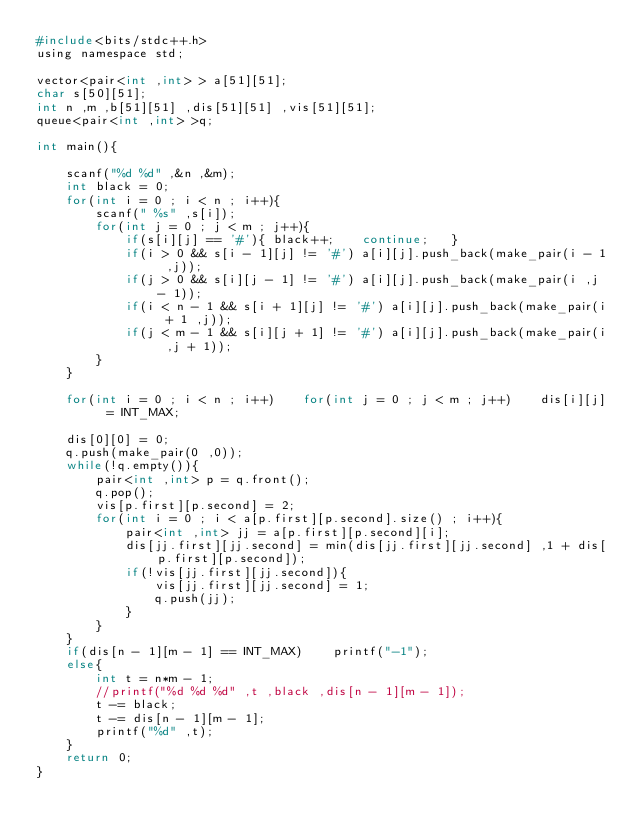Convert code to text. <code><loc_0><loc_0><loc_500><loc_500><_C_>#include<bits/stdc++.h>
using namespace std;

vector<pair<int ,int> > a[51][51];
char s[50][51];
int n ,m ,b[51][51] ,dis[51][51] ,vis[51][51];
queue<pair<int ,int> >q;

int main(){

	scanf("%d %d" ,&n ,&m);
	int black = 0;
	for(int i = 0 ; i < n ; i++){
		scanf(" %s" ,s[i]);
		for(int j = 0 ; j < m ; j++){
			if(s[i][j] == '#'){	black++;	continue;	}
			if(i > 0 && s[i - 1][j] != '#')	a[i][j].push_back(make_pair(i - 1 ,j));
			if(j > 0 && s[i][j - 1] != '#')	a[i][j].push_back(make_pair(i ,j - 1));
			if(i < n - 1 && s[i + 1][j] != '#')	a[i][j].push_back(make_pair(i + 1 ,j));
			if(j < m - 1 && s[i][j + 1] != '#')	a[i][j].push_back(make_pair(i ,j + 1));
		}
	}	
	
	for(int i = 0 ; i < n ; i++)	for(int j = 0 ; j < m ; j++)	dis[i][j] = INT_MAX;
	
	dis[0][0] = 0;
	q.push(make_pair(0 ,0));
	while(!q.empty()){
		pair<int ,int> p = q.front();
		q.pop();
		vis[p.first][p.second] = 2;
		for(int i = 0 ; i < a[p.first][p.second].size() ; i++){
			pair<int ,int> jj = a[p.first][p.second][i];
			dis[jj.first][jj.second] = min(dis[jj.first][jj.second] ,1 + dis[p.first][p.second]);
			if(!vis[jj.first][jj.second]){
				vis[jj.first][jj.second] = 1;
				q.push(jj);
			}
		}
	}
	if(dis[n - 1][m - 1] == INT_MAX)	printf("-1");
	else{
		int t = n*m - 1;
		//printf("%d %d %d" ,t ,black ,dis[n - 1][m - 1]);
		t -= black;
		t -= dis[n - 1][m - 1];
		printf("%d" ,t);
	}
	return 0;
}</code> 